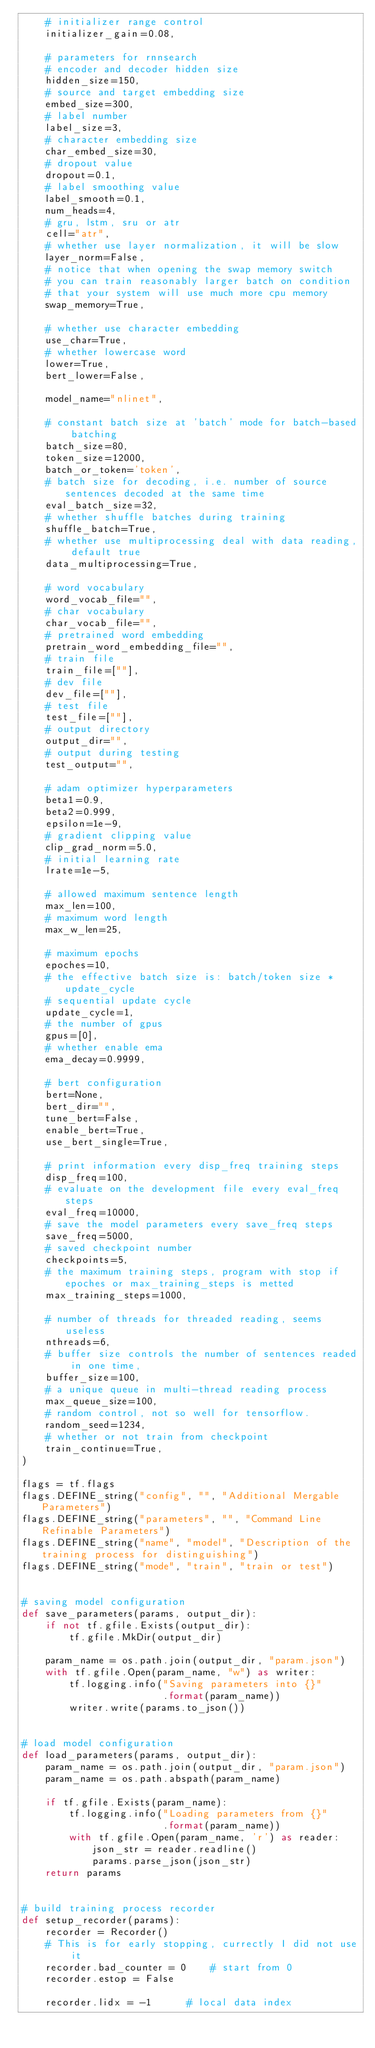<code> <loc_0><loc_0><loc_500><loc_500><_Python_>    # initializer range control
    initializer_gain=0.08,

    # parameters for rnnsearch
    # encoder and decoder hidden size
    hidden_size=150,
    # source and target embedding size
    embed_size=300,
    # label number
    label_size=3,
    # character embedding size
    char_embed_size=30,
    # dropout value
    dropout=0.1,
    # label smoothing value
    label_smooth=0.1,
    num_heads=4,
    # gru, lstm, sru or atr
    cell="atr",
    # whether use layer normalization, it will be slow
    layer_norm=False,
    # notice that when opening the swap memory switch
    # you can train reasonably larger batch on condition
    # that your system will use much more cpu memory
    swap_memory=True,

    # whether use character embedding
    use_char=True,
    # whether lowercase word
    lower=True,
    bert_lower=False,

    model_name="nlinet",

    # constant batch size at 'batch' mode for batch-based batching
    batch_size=80,
    token_size=12000,
    batch_or_token='token',
    # batch size for decoding, i.e. number of source sentences decoded at the same time
    eval_batch_size=32,
    # whether shuffle batches during training
    shuffle_batch=True,
    # whether use multiprocessing deal with data reading, default true
    data_multiprocessing=True,

    # word vocabulary
    word_vocab_file="",
    # char vocabulary
    char_vocab_file="",
    # pretrained word embedding
    pretrain_word_embedding_file="",
    # train file
    train_file=[""],
    # dev file
    dev_file=[""],
    # test file
    test_file=[""],
    # output directory
    output_dir="",
    # output during testing
    test_output="",

    # adam optimizer hyperparameters
    beta1=0.9,
    beta2=0.999,
    epsilon=1e-9,
    # gradient clipping value
    clip_grad_norm=5.0,
    # initial learning rate
    lrate=1e-5,

    # allowed maximum sentence length
    max_len=100,
    # maximum word length
    max_w_len=25,

    # maximum epochs
    epoches=10,
    # the effective batch size is: batch/token size * update_cycle
    # sequential update cycle
    update_cycle=1,
    # the number of gpus
    gpus=[0],
    # whether enable ema
    ema_decay=0.9999,

    # bert configuration
    bert=None,
    bert_dir="",
    tune_bert=False,
    enable_bert=True,
    use_bert_single=True,

    # print information every disp_freq training steps
    disp_freq=100,
    # evaluate on the development file every eval_freq steps
    eval_freq=10000,
    # save the model parameters every save_freq steps
    save_freq=5000,
    # saved checkpoint number
    checkpoints=5,
    # the maximum training steps, program with stop if epoches or max_training_steps is metted
    max_training_steps=1000,

    # number of threads for threaded reading, seems useless
    nthreads=6,
    # buffer size controls the number of sentences readed in one time,
    buffer_size=100,
    # a unique queue in multi-thread reading process
    max_queue_size=100,
    # random control, not so well for tensorflow.
    random_seed=1234,
    # whether or not train from checkpoint
    train_continue=True,
)

flags = tf.flags
flags.DEFINE_string("config", "", "Additional Mergable Parameters")
flags.DEFINE_string("parameters", "", "Command Line Refinable Parameters")
flags.DEFINE_string("name", "model", "Description of the training process for distinguishing")
flags.DEFINE_string("mode", "train", "train or test")


# saving model configuration
def save_parameters(params, output_dir):
    if not tf.gfile.Exists(output_dir):
        tf.gfile.MkDir(output_dir)

    param_name = os.path.join(output_dir, "param.json")
    with tf.gfile.Open(param_name, "w") as writer:
        tf.logging.info("Saving parameters into {}"
                        .format(param_name))
        writer.write(params.to_json())


# load model configuration
def load_parameters(params, output_dir):
    param_name = os.path.join(output_dir, "param.json")
    param_name = os.path.abspath(param_name)

    if tf.gfile.Exists(param_name):
        tf.logging.info("Loading parameters from {}"
                        .format(param_name))
        with tf.gfile.Open(param_name, 'r') as reader:
            json_str = reader.readline()
            params.parse_json(json_str)
    return params


# build training process recorder
def setup_recorder(params):
    recorder = Recorder()
    # This is for early stopping, currectly I did not use it
    recorder.bad_counter = 0    # start from 0
    recorder.estop = False

    recorder.lidx = -1      # local data index</code> 